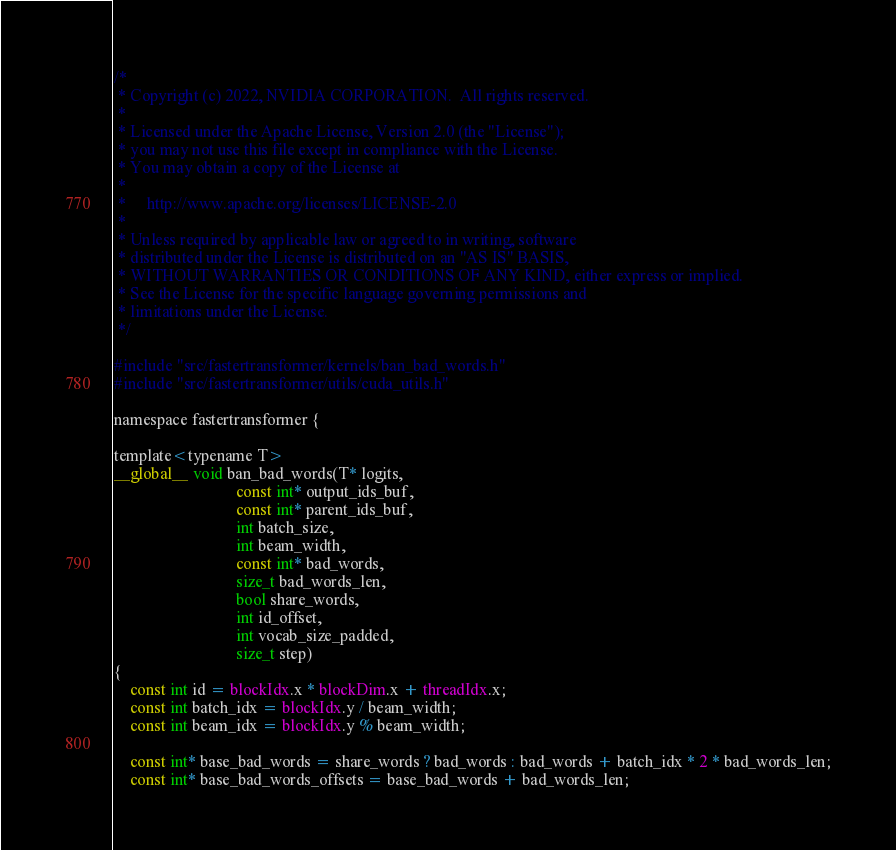<code> <loc_0><loc_0><loc_500><loc_500><_Cuda_>/*
 * Copyright (c) 2022, NVIDIA CORPORATION.  All rights reserved.
 *
 * Licensed under the Apache License, Version 2.0 (the "License");
 * you may not use this file except in compliance with the License.
 * You may obtain a copy of the License at
 *
 *     http://www.apache.org/licenses/LICENSE-2.0
 *
 * Unless required by applicable law or agreed to in writing, software
 * distributed under the License is distributed on an "AS IS" BASIS,
 * WITHOUT WARRANTIES OR CONDITIONS OF ANY KIND, either express or implied.
 * See the License for the specific language governing permissions and
 * limitations under the License.
 */

#include "src/fastertransformer/kernels/ban_bad_words.h"
#include "src/fastertransformer/utils/cuda_utils.h"

namespace fastertransformer {

template<typename T>
__global__ void ban_bad_words(T* logits,
                              const int* output_ids_buf,
                              const int* parent_ids_buf,
                              int batch_size,
                              int beam_width,
                              const int* bad_words,
                              size_t bad_words_len,
                              bool share_words,
                              int id_offset,
                              int vocab_size_padded,
                              size_t step)
{
    const int id = blockIdx.x * blockDim.x + threadIdx.x;
    const int batch_idx = blockIdx.y / beam_width;
    const int beam_idx = blockIdx.y % beam_width;

    const int* base_bad_words = share_words ? bad_words : bad_words + batch_idx * 2 * bad_words_len;
    const int* base_bad_words_offsets = base_bad_words + bad_words_len;
</code> 